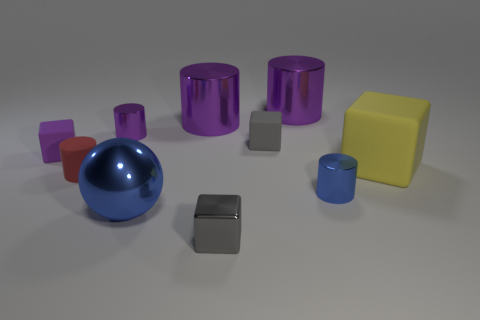Subtract all gray spheres. How many purple cylinders are left? 3 Subtract 1 blocks. How many blocks are left? 3 Subtract all small shiny blocks. How many blocks are left? 3 Subtract all red cylinders. How many cylinders are left? 4 Subtract all red cylinders. Subtract all purple cubes. How many cylinders are left? 4 Subtract all balls. How many objects are left? 9 Subtract all small matte objects. Subtract all tiny blue metallic things. How many objects are left? 6 Add 5 tiny red rubber cylinders. How many tiny red rubber cylinders are left? 6 Add 3 big cylinders. How many big cylinders exist? 5 Subtract 0 cyan cylinders. How many objects are left? 10 